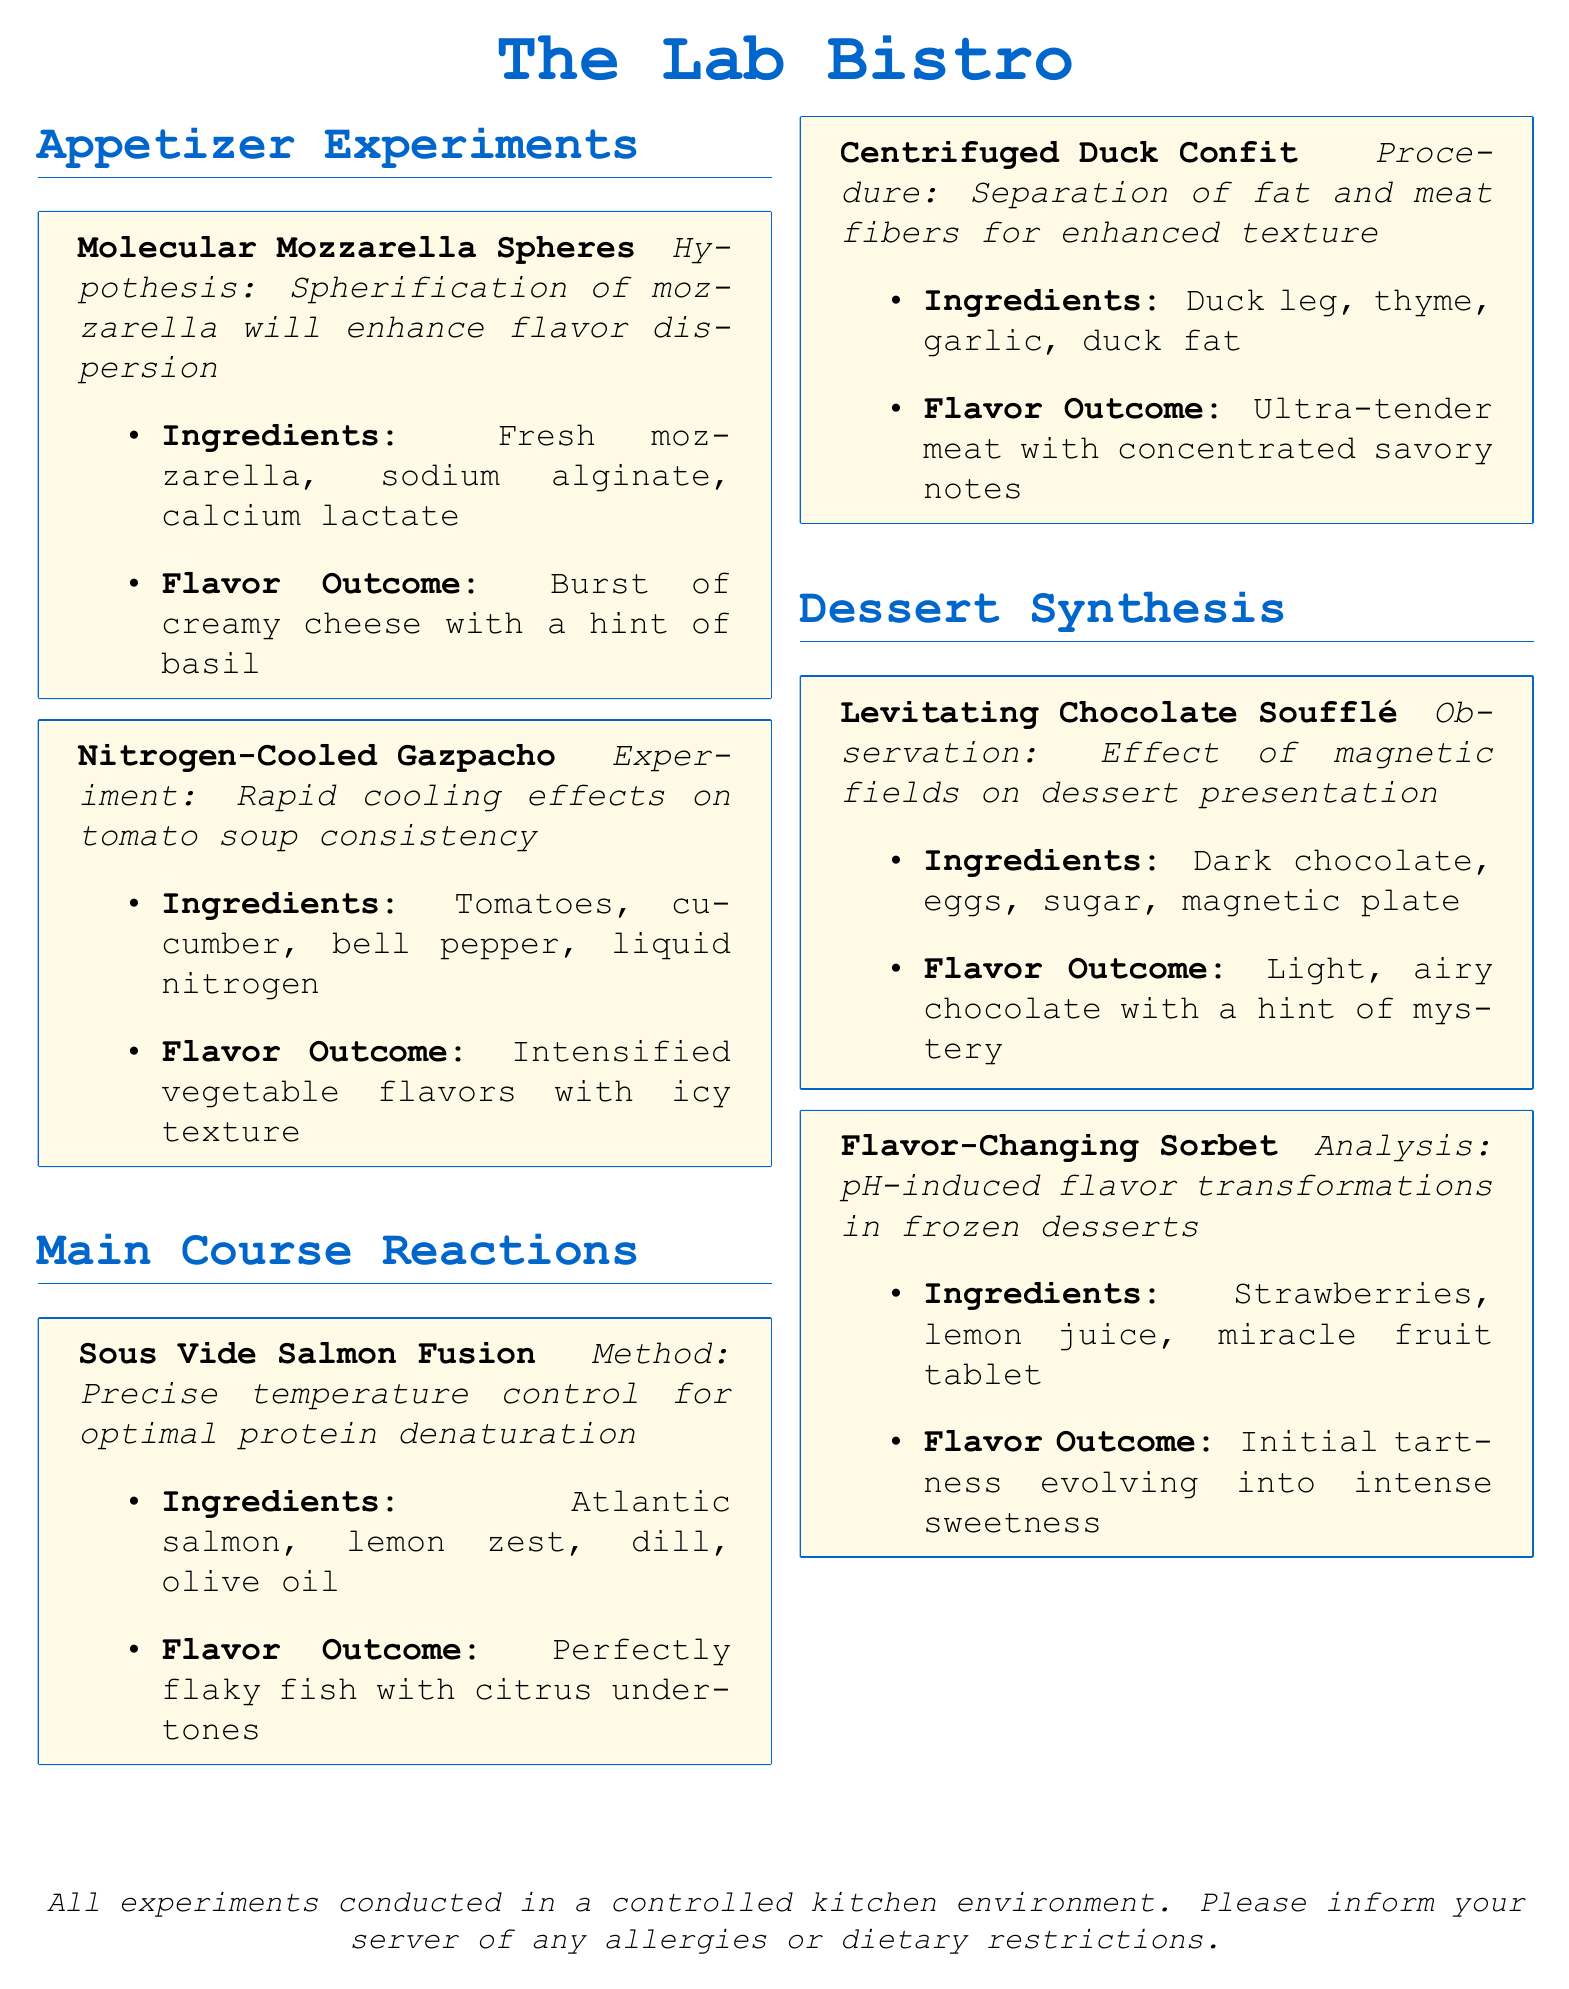What is the name of the appetizer that includes sodium alginate? The appetizer featuring sodium alginate is listed as "Molecular Mozzarella Spheres."
Answer: Molecular Mozzarella Spheres What experimental method is used for the salmon dish? The method used for the salmon dish is "Precise temperature control for optimal protein denaturation."
Answer: Sous Vide How many main course items are listed in the menu? The menu lists two main course items, "Sous Vide Salmon Fusion" and "Centrifuged Duck Confit."
Answer: 2 What is the flavor outcome of the nitrogen-cooled gazpacho? The flavor outcome of the nitrogen-cooled gazpacho is "Intensified vegetable flavors with icy texture."
Answer: Intensified vegetable flavors with icy texture What hypothesis is proposed for the molecular mozzarella spheres? The hypothesis proposed for the molecular mozzarella spheres is that "Spherification of mozzarella will enhance flavor dispersion."
Answer: Spherification of mozzarella will enhance flavor dispersion What is included in the ingredients for the flavor-changing sorbet? The ingredients for the flavor-changing sorbet include "Strawberries, lemon juice, miracle fruit tablet."
Answer: Strawberries, lemon juice, miracle fruit tablet What is a key feature of the levitating chocolate soufflé's presentation? A key feature of the levitating chocolate soufflé's presentation is the "Effect of magnetic fields."
Answer: Effect of magnetic fields Which dessert has an analysis related to pH-induced flavor transformations? The dessert that has an analysis related to pH-induced flavor transformations is the "Flavor-Changing Sorbet."
Answer: Flavor-Changing Sorbet 